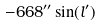Convert formula to latex. <formula><loc_0><loc_0><loc_500><loc_500>- 6 6 8 ^ { \prime \prime } \sin ( l ^ { \prime } )</formula> 